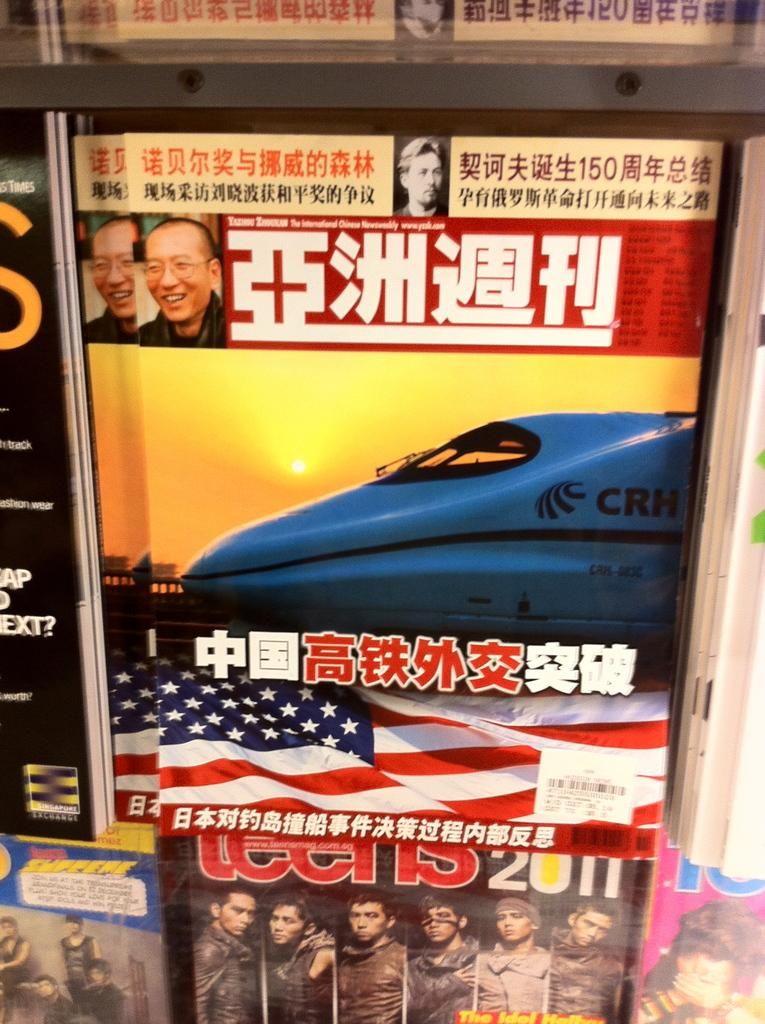What can be seen in the image that has text on it? There are posts in the image that have text on them. What languages can be seen on the posts? The text on the posts is in different languages. How does the writer feel about the visitor in the image? There is no writer or visitor present in the image; it only features posts with text in different languages. 